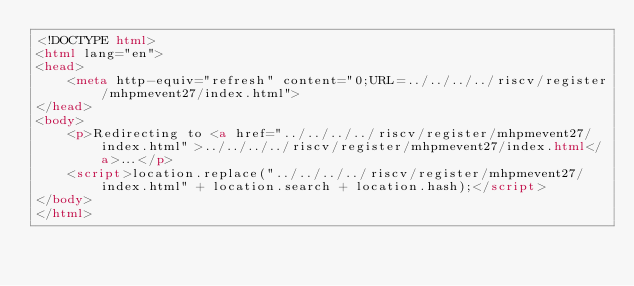Convert code to text. <code><loc_0><loc_0><loc_500><loc_500><_HTML_><!DOCTYPE html>
<html lang="en">
<head>
    <meta http-equiv="refresh" content="0;URL=../../../../riscv/register/mhpmevent27/index.html">
</head>
<body>
    <p>Redirecting to <a href="../../../../riscv/register/mhpmevent27/index.html">../../../../riscv/register/mhpmevent27/index.html</a>...</p>
    <script>location.replace("../../../../riscv/register/mhpmevent27/index.html" + location.search + location.hash);</script>
</body>
</html></code> 